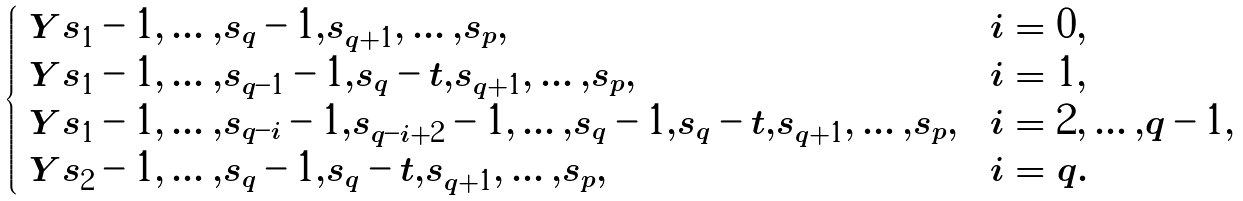Convert formula to latex. <formula><loc_0><loc_0><loc_500><loc_500>\begin{cases} \ Y { s _ { 1 } - 1 , \dots , s _ { q } - 1 , s _ { q + 1 } , \dots , s _ { p } } , & i = 0 , \\ \ Y { s _ { 1 } - 1 , \dots , s _ { q - 1 } - 1 , s _ { q } - t , s _ { q + 1 } , \dots , s _ { p } } , & i = 1 , \\ \ Y { s _ { 1 } - 1 , \dots , s _ { q - i } - 1 , s _ { q - i + 2 } - 1 , \dots , s _ { q } - 1 , s _ { q } - t , s _ { q + 1 } , \dots , s _ { p } } , & i = 2 , \dots , q - 1 , \\ \ Y { s _ { 2 } - 1 , \dots , s _ { q } - 1 , s _ { q } - t , s _ { q + 1 } , \dots , s _ { p } } , & i = q . \end{cases}</formula> 